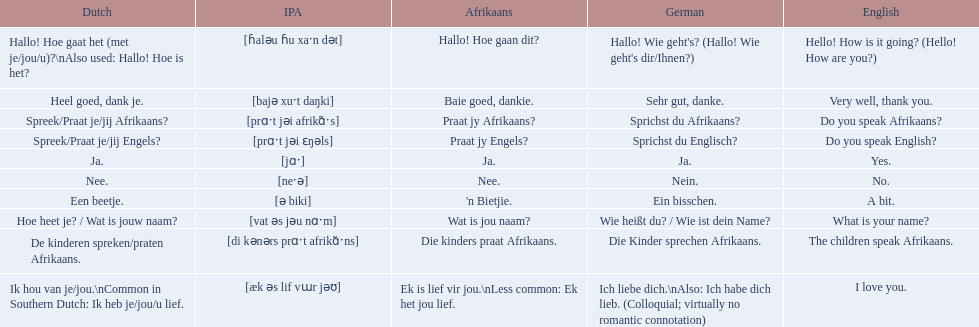What are the listed afrikaans phrases? Hallo! Hoe gaan dit?, Baie goed, dankie., Praat jy Afrikaans?, Praat jy Engels?, Ja., Nee., 'n Bietjie., Wat is jou naam?, Die kinders praat Afrikaans., Ek is lief vir jou.\nLess common: Ek het jou lief. Which is die kinders praat afrikaans? Die kinders praat Afrikaans. What is its german translation? Die Kinder sprechen Afrikaans. 